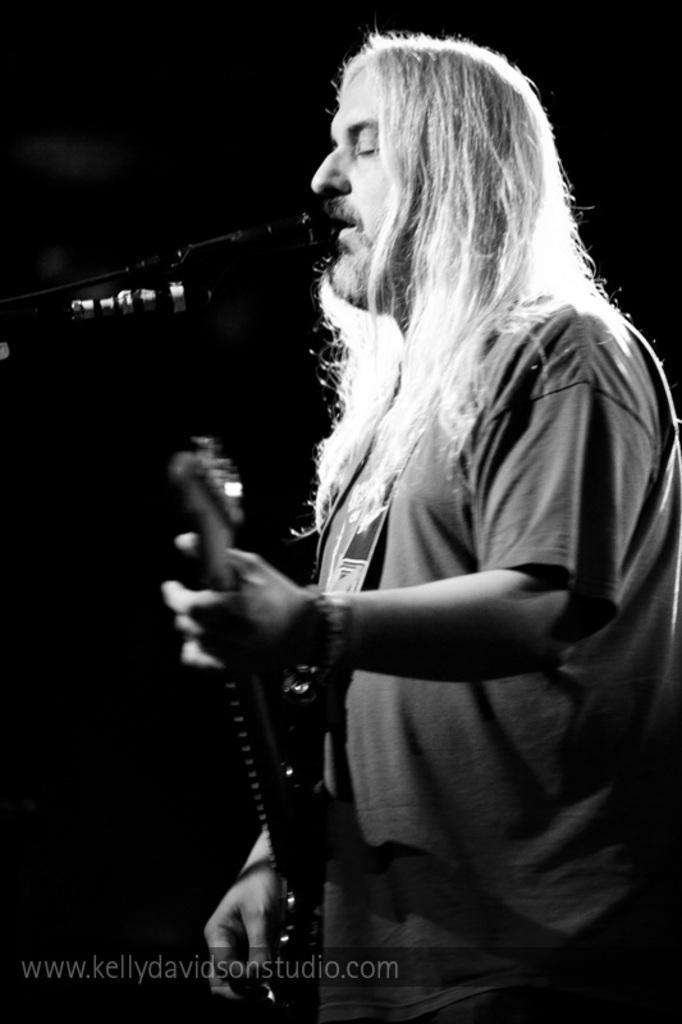Could you give a brief overview of what you see in this image? In a picture there is only one man playing a guitar and singing in the microphone and he is wearing a t-shirt and having a long hair. 